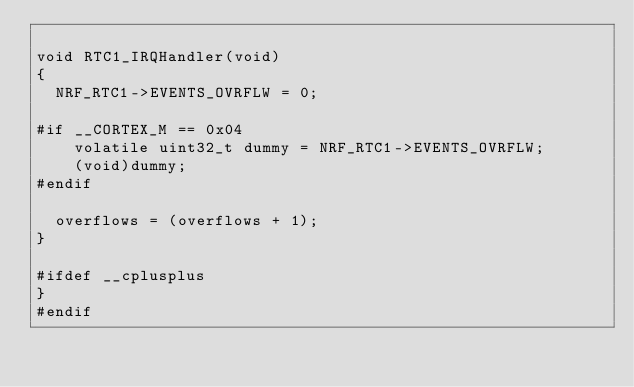<code> <loc_0><loc_0><loc_500><loc_500><_C_>
void RTC1_IRQHandler(void)
{
  NRF_RTC1->EVENTS_OVRFLW = 0;

#if __CORTEX_M == 0x04
    volatile uint32_t dummy = NRF_RTC1->EVENTS_OVRFLW;
    (void)dummy;
#endif

  overflows = (overflows + 1);
}

#ifdef __cplusplus
}
#endif
</code> 